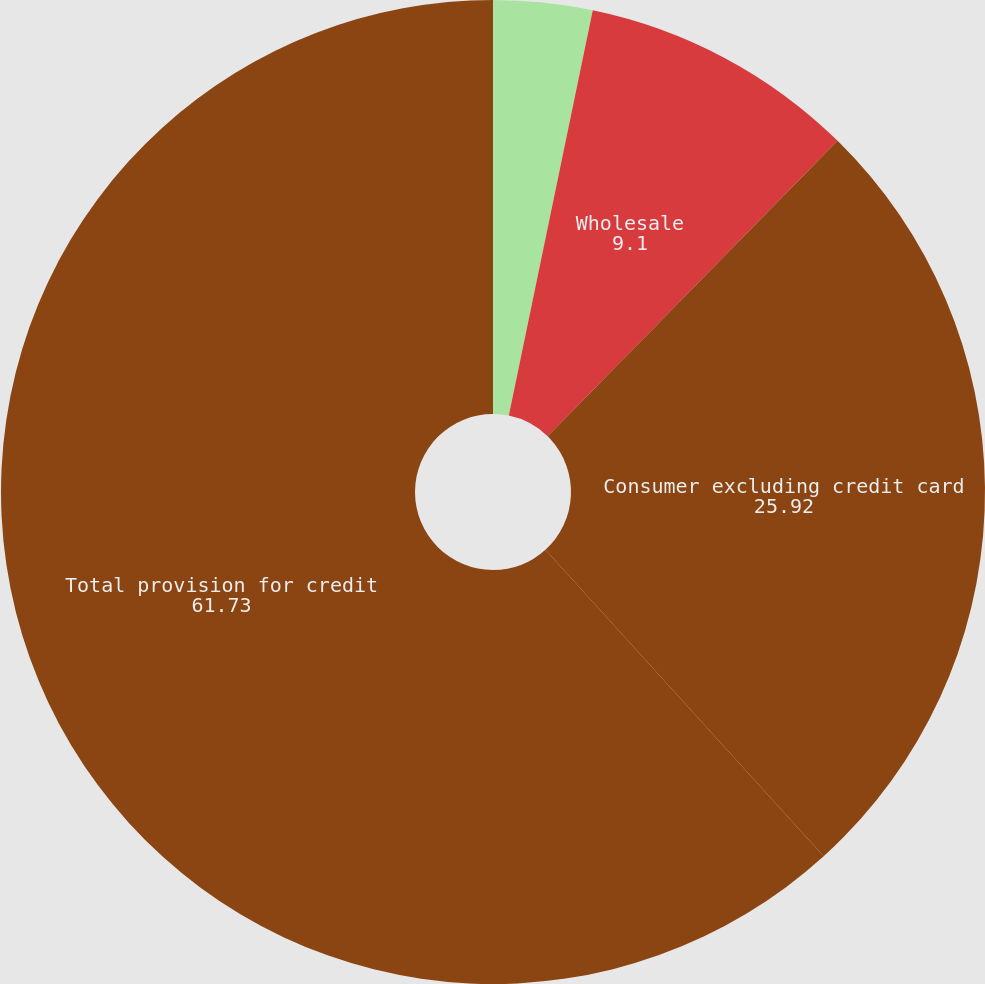<chart> <loc_0><loc_0><loc_500><loc_500><pie_chart><fcel>(in millions)<fcel>Wholesale<fcel>Consumer excluding credit card<fcel>Total provision for credit<nl><fcel>3.25%<fcel>9.1%<fcel>25.92%<fcel>61.73%<nl></chart> 